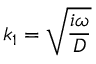Convert formula to latex. <formula><loc_0><loc_0><loc_500><loc_500>k _ { 1 } = \sqrt { \frac { i \omega } { D } }</formula> 